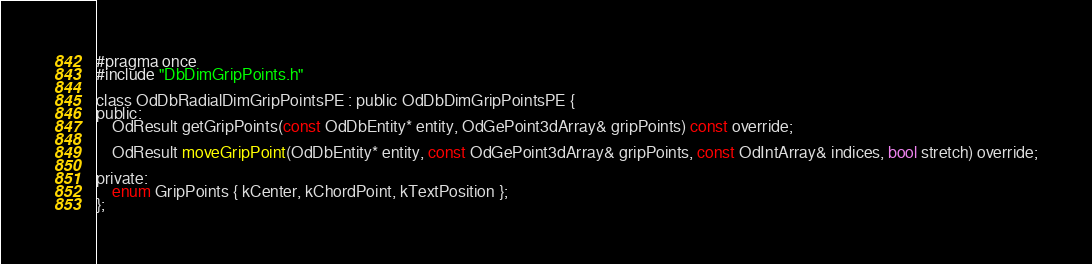<code> <loc_0><loc_0><loc_500><loc_500><_C_>#pragma once
#include "DbDimGripPoints.h"

class OdDbRadialDimGripPointsPE : public OdDbDimGripPointsPE {
public:
	OdResult getGripPoints(const OdDbEntity* entity, OdGePoint3dArray& gripPoints) const override;

	OdResult moveGripPoint(OdDbEntity* entity, const OdGePoint3dArray& gripPoints, const OdIntArray& indices, bool stretch) override;

private:
	enum GripPoints { kCenter, kChordPoint, kTextPosition };
};
</code> 